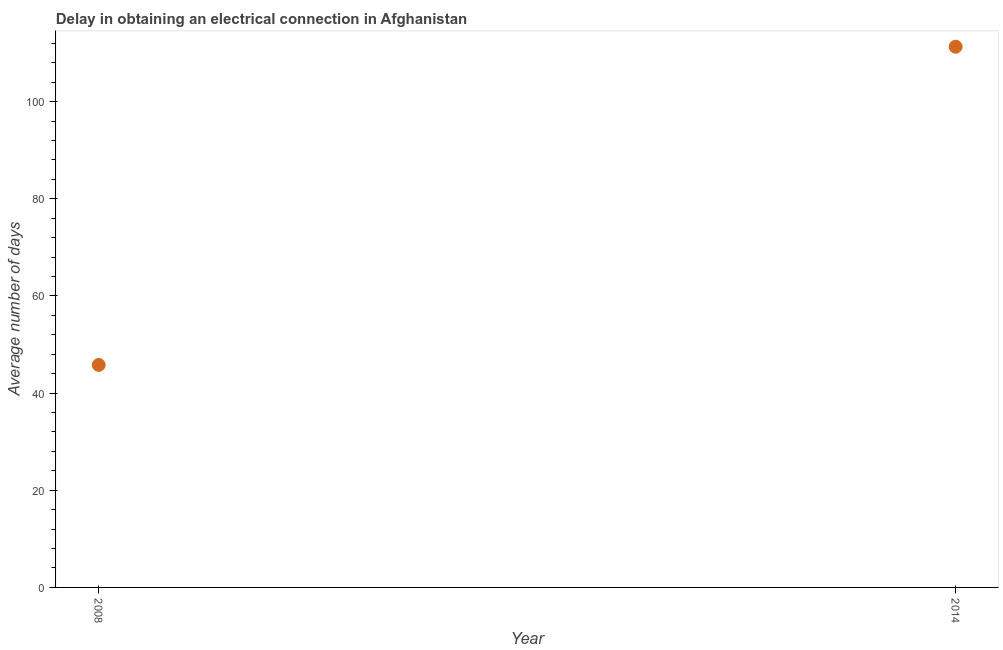What is the dalay in electrical connection in 2008?
Keep it short and to the point. 45.8. Across all years, what is the maximum dalay in electrical connection?
Ensure brevity in your answer.  111.3. Across all years, what is the minimum dalay in electrical connection?
Your answer should be very brief. 45.8. What is the sum of the dalay in electrical connection?
Make the answer very short. 157.1. What is the difference between the dalay in electrical connection in 2008 and 2014?
Provide a short and direct response. -65.5. What is the average dalay in electrical connection per year?
Keep it short and to the point. 78.55. What is the median dalay in electrical connection?
Offer a terse response. 78.55. What is the ratio of the dalay in electrical connection in 2008 to that in 2014?
Offer a very short reply. 0.41. How many years are there in the graph?
Ensure brevity in your answer.  2. What is the difference between two consecutive major ticks on the Y-axis?
Provide a succinct answer. 20. Are the values on the major ticks of Y-axis written in scientific E-notation?
Offer a terse response. No. Does the graph contain any zero values?
Keep it short and to the point. No. What is the title of the graph?
Provide a succinct answer. Delay in obtaining an electrical connection in Afghanistan. What is the label or title of the Y-axis?
Keep it short and to the point. Average number of days. What is the Average number of days in 2008?
Keep it short and to the point. 45.8. What is the Average number of days in 2014?
Provide a short and direct response. 111.3. What is the difference between the Average number of days in 2008 and 2014?
Your answer should be very brief. -65.5. What is the ratio of the Average number of days in 2008 to that in 2014?
Keep it short and to the point. 0.41. 